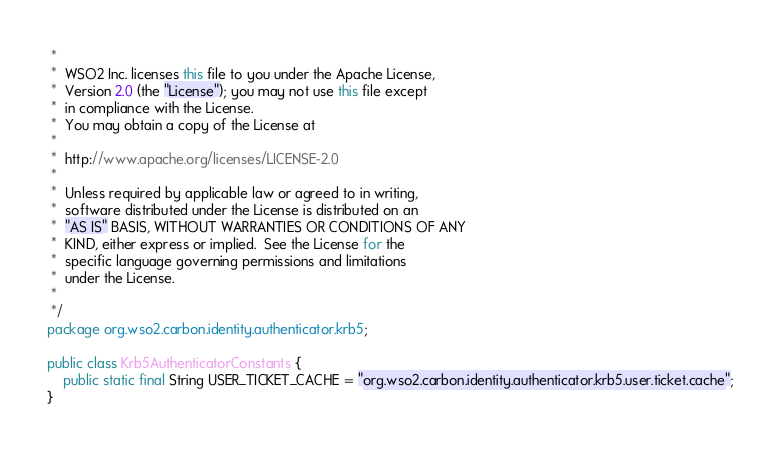<code> <loc_0><loc_0><loc_500><loc_500><_Java_> *
 *  WSO2 Inc. licenses this file to you under the Apache License,
 *  Version 2.0 (the "License"); you may not use this file except
 *  in compliance with the License.
 *  You may obtain a copy of the License at
 *
 *  http://www.apache.org/licenses/LICENSE-2.0
 *
 *  Unless required by applicable law or agreed to in writing,
 *  software distributed under the License is distributed on an
 *  "AS IS" BASIS, WITHOUT WARRANTIES OR CONDITIONS OF ANY
 *  KIND, either express or implied.  See the License for the
 *  specific language governing permissions and limitations
 *  under the License.
 *
 */
package org.wso2.carbon.identity.authenticator.krb5;

public class Krb5AuthenticatorConstants {
    public static final String USER_TICKET_CACHE = "org.wso2.carbon.identity.authenticator.krb5.user.ticket.cache";
}
</code> 